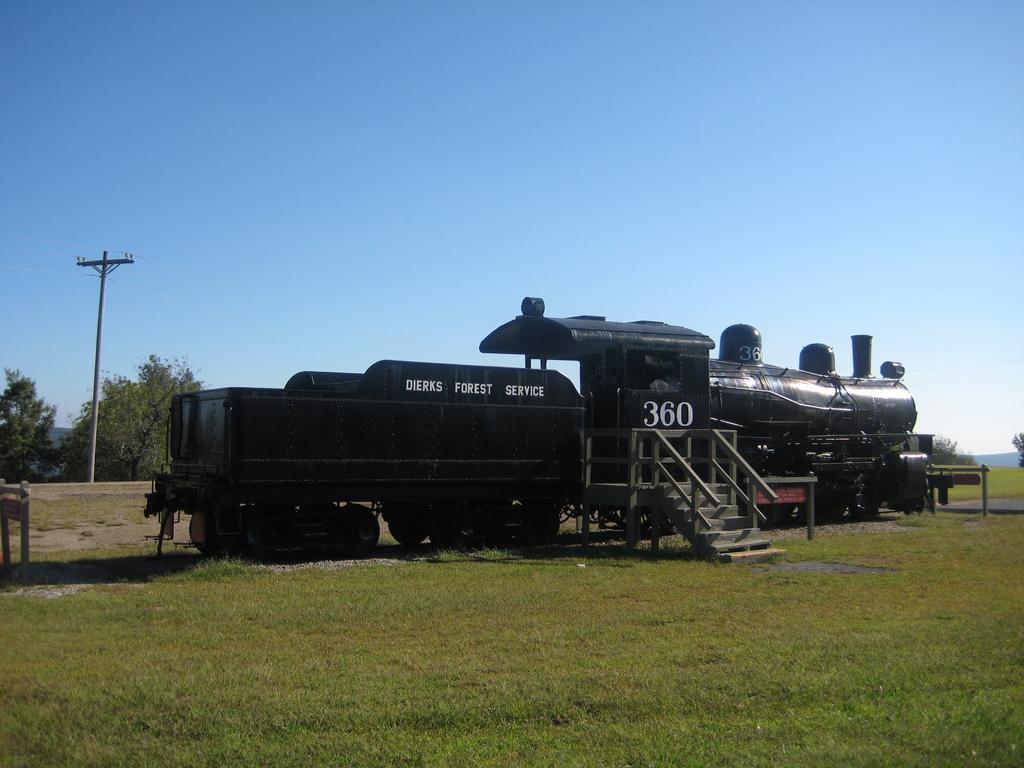Could you give a brief overview of what you see in this image? In this image there is a train engine and there are stairs on the surface of the grass. In the background there is a utility pole, trees and the sky. 